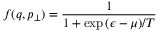Convert formula to latex. <formula><loc_0><loc_0><loc_500><loc_500>f ( q , p _ { \bot } ) = \frac { 1 } { 1 + \exp { ( \epsilon - \mu ) / T } }</formula> 